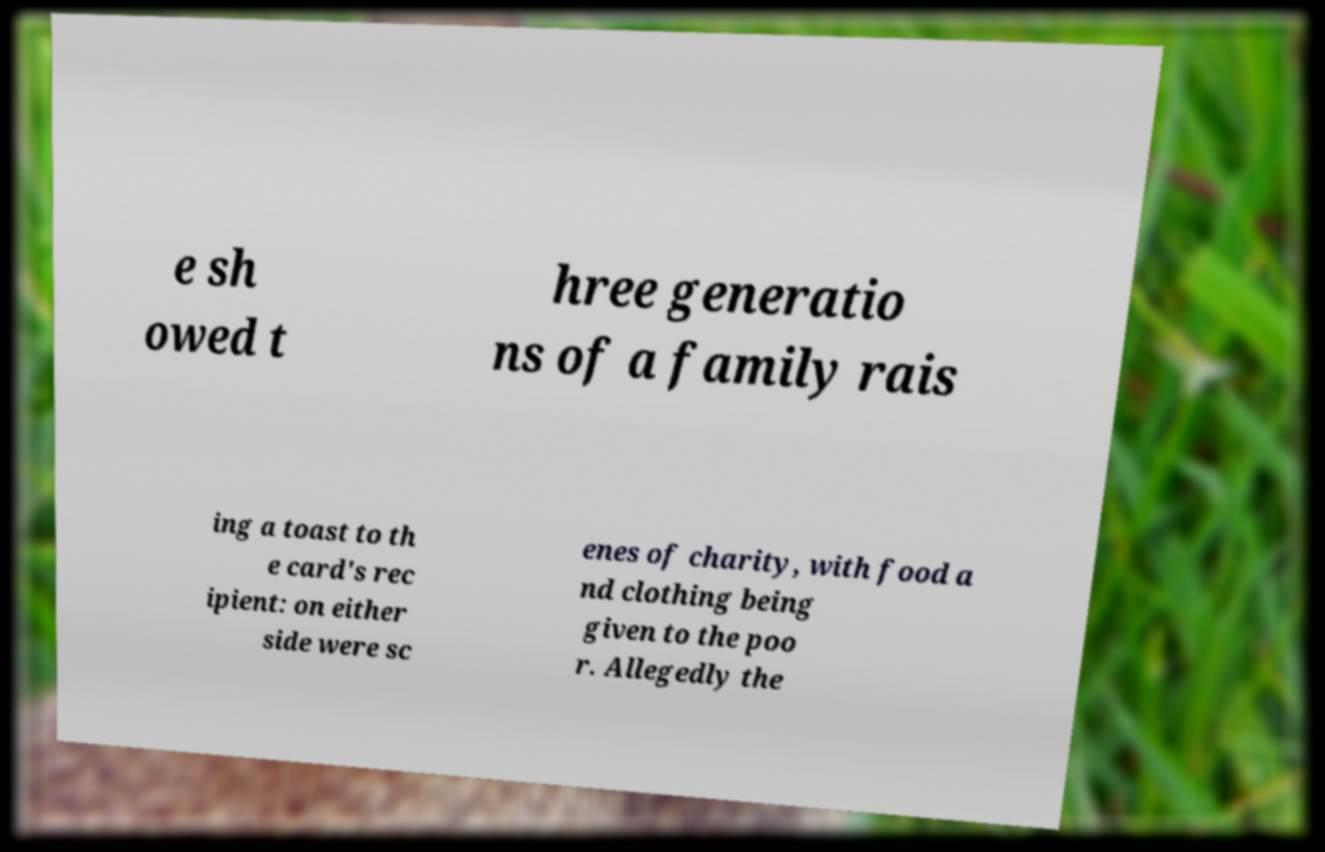Please read and relay the text visible in this image. What does it say? e sh owed t hree generatio ns of a family rais ing a toast to th e card's rec ipient: on either side were sc enes of charity, with food a nd clothing being given to the poo r. Allegedly the 